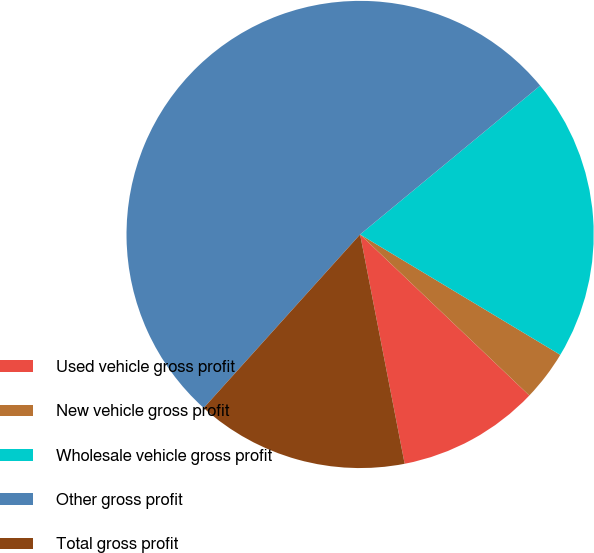Convert chart to OTSL. <chart><loc_0><loc_0><loc_500><loc_500><pie_chart><fcel>Used vehicle gross profit<fcel>New vehicle gross profit<fcel>Wholesale vehicle gross profit<fcel>Other gross profit<fcel>Total gross profit<nl><fcel>9.84%<fcel>3.49%<fcel>19.61%<fcel>52.33%<fcel>14.73%<nl></chart> 